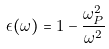<formula> <loc_0><loc_0><loc_500><loc_500>\epsilon ( \omega ) = 1 - \frac { \omega _ { P } ^ { 2 } } { \omega ^ { 2 } }</formula> 